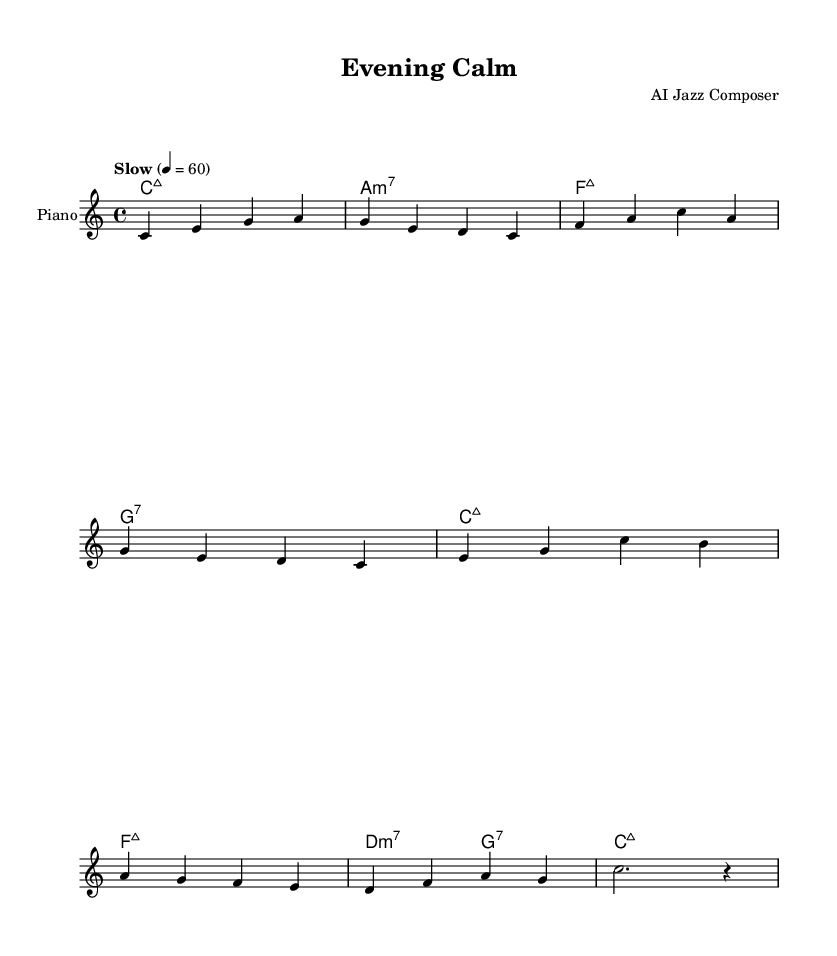What is the key signature of this music? The key signature is indicated at the beginning of the sheet music. It has no sharps or flats, which defines it as C major.
Answer: C major What is the time signature of this piece? The time signature is shown as a fraction at the beginning, with 4 on top and 4 on the bottom, indicating that there are four beats in each measure and a quarter note gets one beat.
Answer: 4/4 What is the tempo marking for this composition? The tempo marking is written above the staff as "Slow" and indicates a speed of 60 beats per minute, which reflects a relaxed pace suitable for unwinding.
Answer: Slow How many measures are there in the melody? By counting the groupings of notes between the bar lines, there are a total of 8 measures present in the melody section of the sheet music.
Answer: 8 What type of chords are primarily used in the harmonies? The chords indicated in the harmonies are primarily major and minor seventh chords, typical for jazz ballads, which provide a rich harmonic texture.
Answer: Major and minor seventh Which section is marked as the “Piano” part? The label "Piano" is displayed under the staff indicating that this part is intended for piano performance, separating it from any chord names provided above.
Answer: Piano 